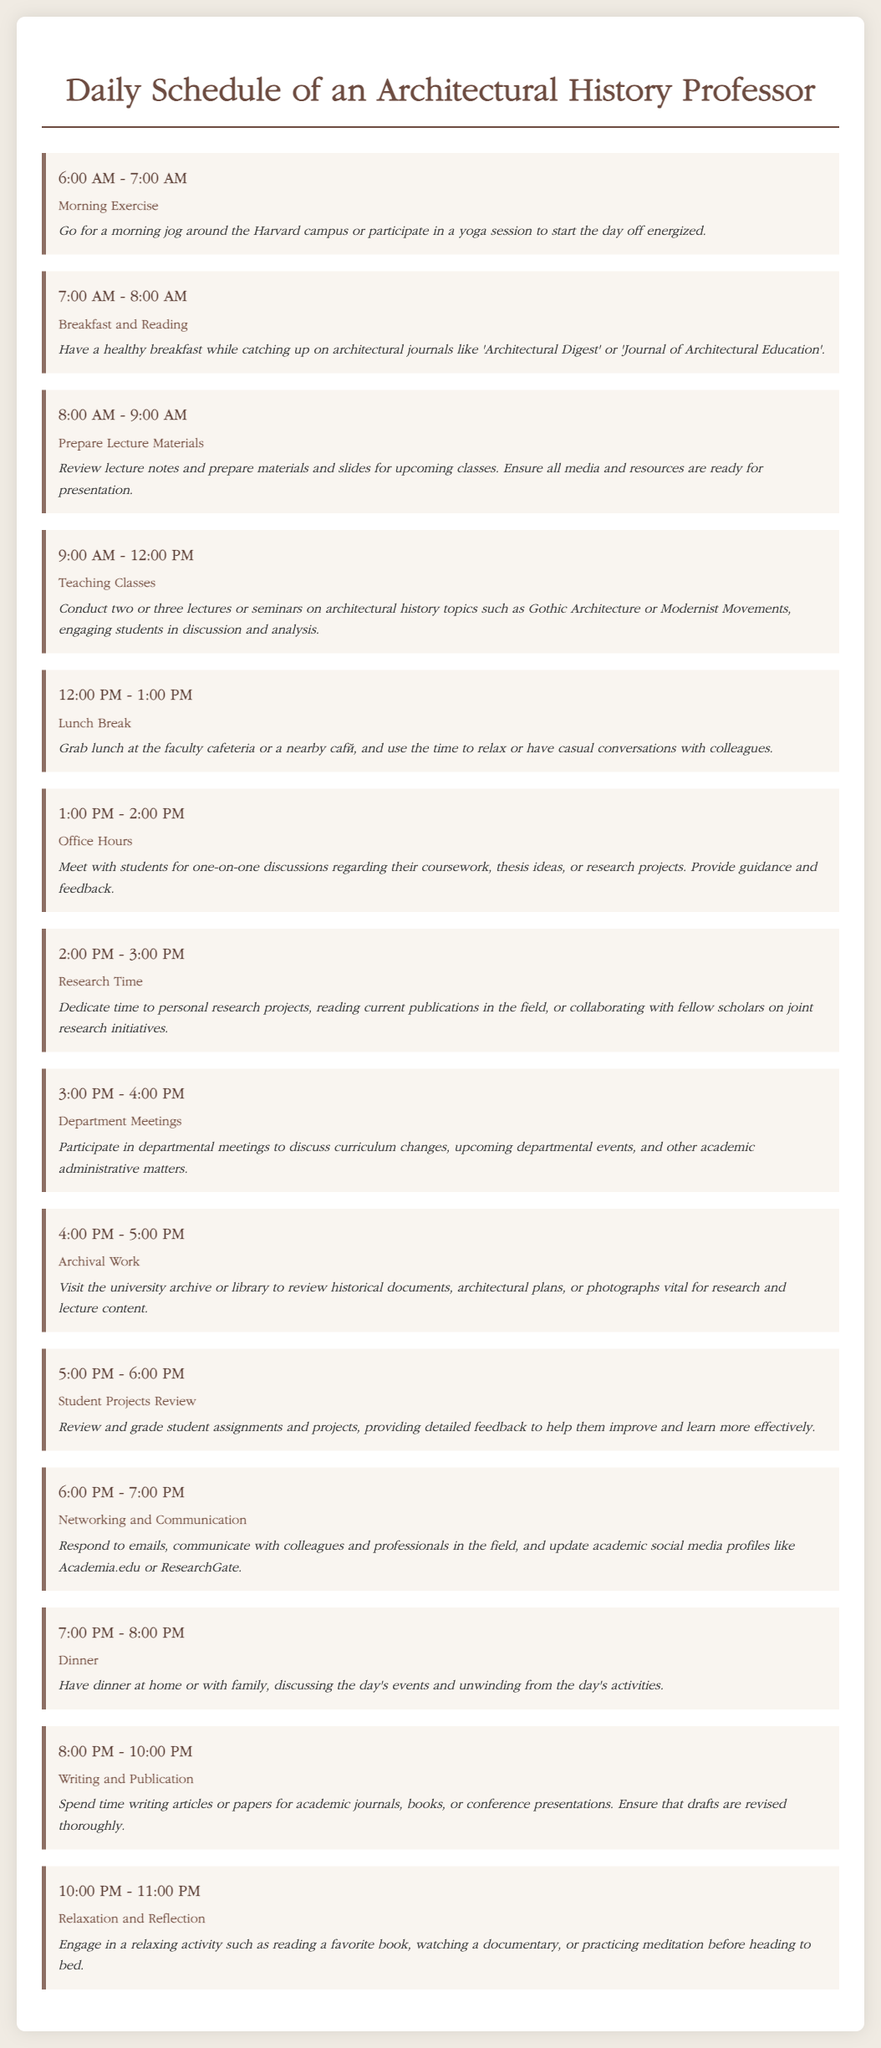what time does the professor start morning exercise? Morning exercise begins at 6:00 AM.
Answer: 6:00 AM how long is the lunch break? The lunch break lasts for one hour, from 12:00 PM to 1:00 PM.
Answer: 1 hour what activity is scheduled from 3:00 PM to 4:00 PM? This time is allocated for department meetings in the schedule.
Answer: Department Meetings how many hours are dedicated to writing and publication? The schedule allocates two hours for writing and publication from 8:00 PM to 10:00 PM.
Answer: 2 hours what does the professor do during office hours? During office hours, the professor meets with students for one-on-one discussions about coursework.
Answer: One-on-one discussions what is the main focus of research time? The main focus of research time is on personal research projects and collaboration with fellow scholars.
Answer: Personal research projects which activity includes reading architectural journals? The activity that includes reading architectural journals occurs during breakfast and reading.
Answer: Breakfast and Reading what is the last activity in the daily schedule? The last activity scheduled for the day is relaxation and reflection.
Answer: Relaxation and Reflection 